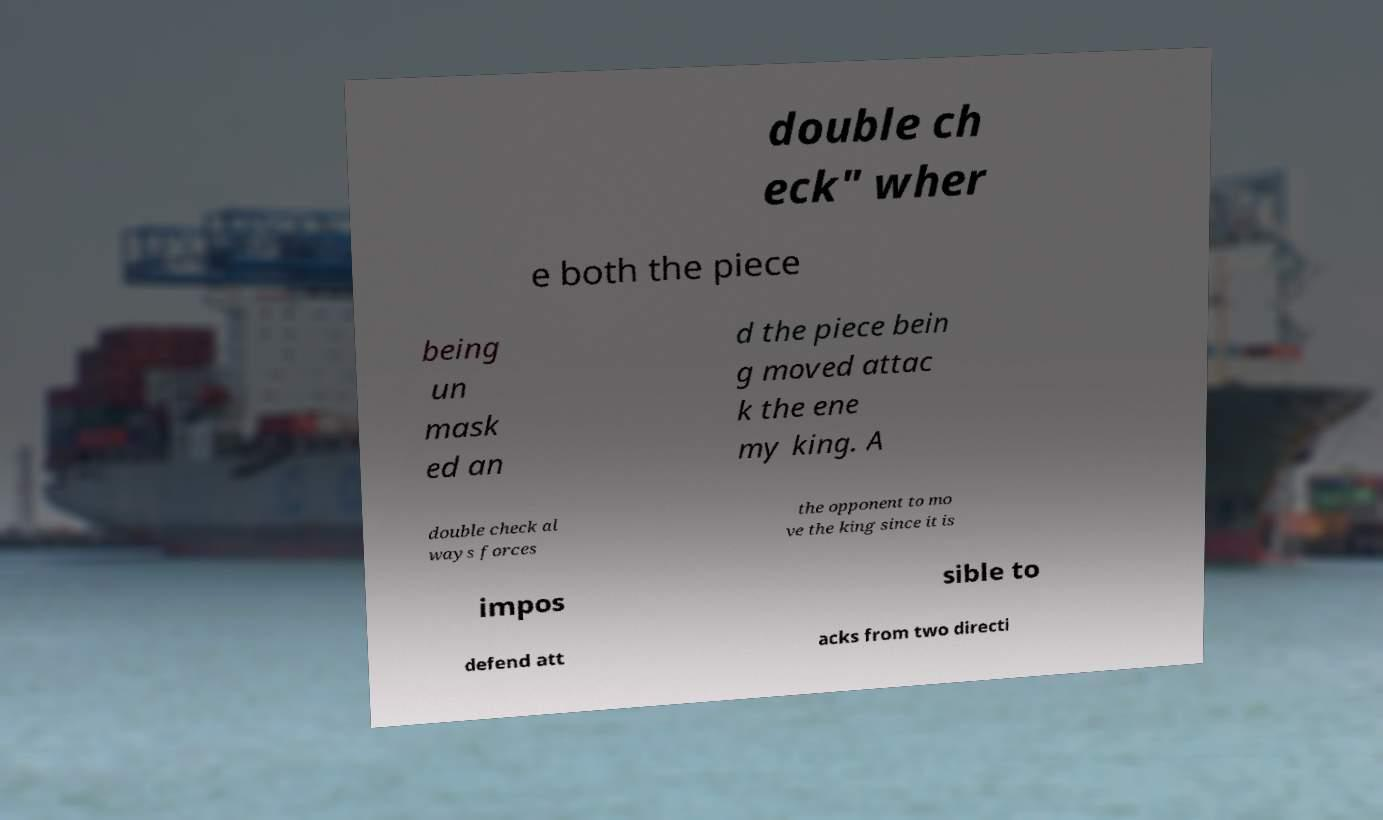Could you assist in decoding the text presented in this image and type it out clearly? double ch eck" wher e both the piece being un mask ed an d the piece bein g moved attac k the ene my king. A double check al ways forces the opponent to mo ve the king since it is impos sible to defend att acks from two directi 